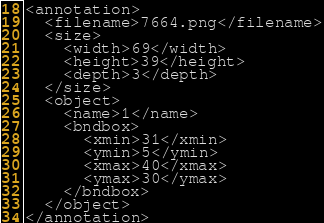Convert code to text. <code><loc_0><loc_0><loc_500><loc_500><_XML_><annotation>
  <filename>7664.png</filename>
  <size>
    <width>69</width>
    <height>39</height>
    <depth>3</depth>
  </size>
  <object>
    <name>1</name>
    <bndbox>
      <xmin>31</xmin>
      <ymin>5</ymin>
      <xmax>40</xmax>
      <ymax>30</ymax>
    </bndbox>
  </object>
</annotation>
</code> 